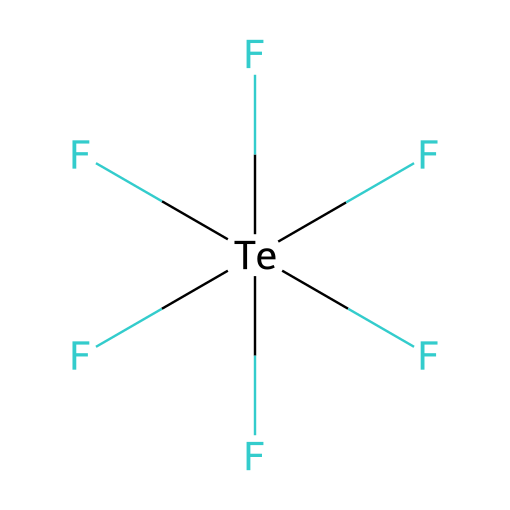What is the name of the compound represented by this structure? The structure corresponds to tellurium hexafluoride, as indicated by the element symbol "Te" and the six fluorine atoms attached to it.
Answer: tellurium hexafluoride How many fluorine atoms are bonded to the tellurium atom? By counting the fluorine atoms present in the structure (F[Te](F)(F)(F)(F)F), we see there are six fluorine atoms attached to the tellurium atom.
Answer: six Is tellurium hexafluoride a hypervalent compound? Yes, tellurium hexafluoride is hypervalent because the tellurium atom has more than four electron pairs (six fluorine atoms lead to six bonding pairs).
Answer: yes What is the coordination number of tellurium in this molecule? The coordination number refers to the number of atoms directly bonded to the central atom, which in this case is six fluorine atoms bonded to the tellurium.
Answer: six What type of chemical bonding is primarily present in tellurium hexafluoride? The predominant type of chemical bonding in this molecule is covalent bonding, characterized here by the sharing of electrons between the tellurium and fluorine atoms.
Answer: covalent Why is tellurium hexafluoride considered a suitable material for lens coatings? Tellurium hexafluoride has unique optical properties and a stable arrangement that can enhance anti-reflective coatings in advanced lens technology.
Answer: unique optical properties What phenomenon allows tellurium hexafluoride to exhibit hypervalency? Hypervalency in tellurium hexafluoride occurs due to the ability of the tellurium atom to utilize d orbitals for bonding with six fluorine atoms, exceeding the octet rule.
Answer: d orbitals 